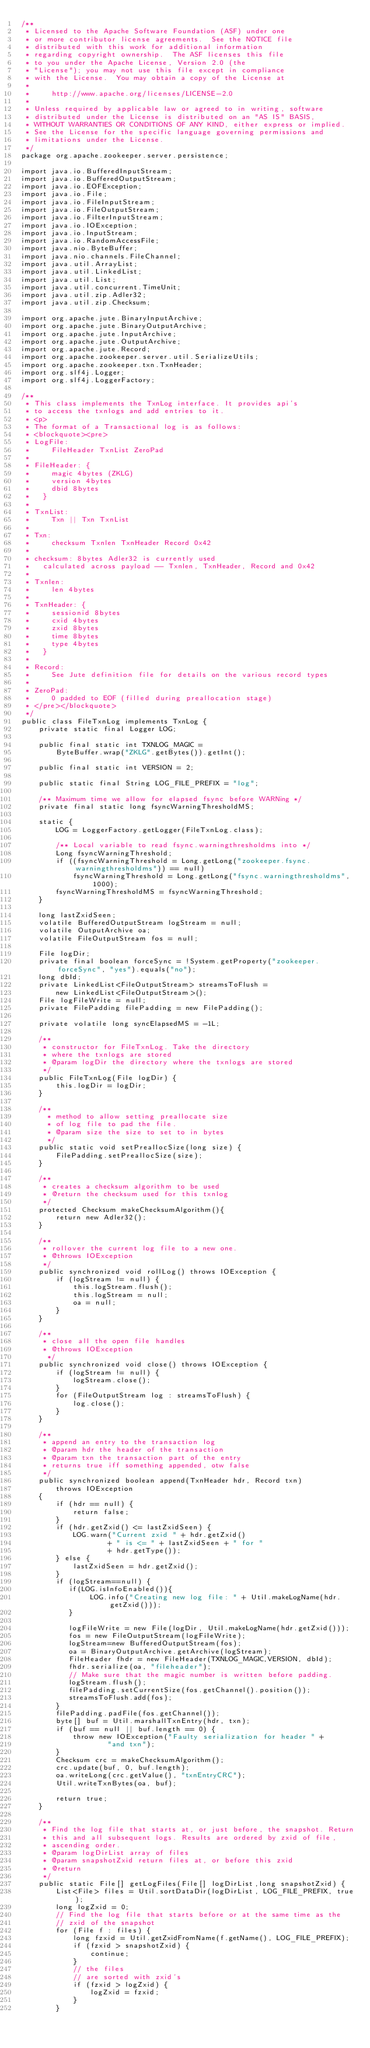Convert code to text. <code><loc_0><loc_0><loc_500><loc_500><_Java_>/**
 * Licensed to the Apache Software Foundation (ASF) under one
 * or more contributor license agreements.  See the NOTICE file
 * distributed with this work for additional information
 * regarding copyright ownership.  The ASF licenses this file
 * to you under the Apache License, Version 2.0 (the
 * "License"); you may not use this file except in compliance
 * with the License.  You may obtain a copy of the License at
 *
 *     http://www.apache.org/licenses/LICENSE-2.0
 *
 * Unless required by applicable law or agreed to in writing, software
 * distributed under the License is distributed on an "AS IS" BASIS,
 * WITHOUT WARRANTIES OR CONDITIONS OF ANY KIND, either express or implied.
 * See the License for the specific language governing permissions and
 * limitations under the License.
 */
package org.apache.zookeeper.server.persistence;

import java.io.BufferedInputStream;
import java.io.BufferedOutputStream;
import java.io.EOFException;
import java.io.File;
import java.io.FileInputStream;
import java.io.FileOutputStream;
import java.io.FilterInputStream;
import java.io.IOException;
import java.io.InputStream;
import java.io.RandomAccessFile;
import java.nio.ByteBuffer;
import java.nio.channels.FileChannel;
import java.util.ArrayList;
import java.util.LinkedList;
import java.util.List;
import java.util.concurrent.TimeUnit;
import java.util.zip.Adler32;
import java.util.zip.Checksum;

import org.apache.jute.BinaryInputArchive;
import org.apache.jute.BinaryOutputArchive;
import org.apache.jute.InputArchive;
import org.apache.jute.OutputArchive;
import org.apache.jute.Record;
import org.apache.zookeeper.server.util.SerializeUtils;
import org.apache.zookeeper.txn.TxnHeader;
import org.slf4j.Logger;
import org.slf4j.LoggerFactory;

/**
 * This class implements the TxnLog interface. It provides api's
 * to access the txnlogs and add entries to it.
 * <p>
 * The format of a Transactional log is as follows:
 * <blockquote><pre>
 * LogFile:
 *     FileHeader TxnList ZeroPad
 *
 * FileHeader: {
 *     magic 4bytes (ZKLG)
 *     version 4bytes
 *     dbid 8bytes
 *   }
 *
 * TxnList:
 *     Txn || Txn TxnList
 *
 * Txn:
 *     checksum Txnlen TxnHeader Record 0x42
 *
 * checksum: 8bytes Adler32 is currently used
 *   calculated across payload -- Txnlen, TxnHeader, Record and 0x42
 *
 * Txnlen:
 *     len 4bytes
 *
 * TxnHeader: {
 *     sessionid 8bytes
 *     cxid 4bytes
 *     zxid 8bytes
 *     time 8bytes
 *     type 4bytes
 *   }
 *
 * Record:
 *     See Jute definition file for details on the various record types
 *
 * ZeroPad:
 *     0 padded to EOF (filled during preallocation stage)
 * </pre></blockquote>
 */
public class FileTxnLog implements TxnLog {
    private static final Logger LOG;

    public final static int TXNLOG_MAGIC =
        ByteBuffer.wrap("ZKLG".getBytes()).getInt();

    public final static int VERSION = 2;

    public static final String LOG_FILE_PREFIX = "log";

    /** Maximum time we allow for elapsed fsync before WARNing */
    private final static long fsyncWarningThresholdMS;

    static {
        LOG = LoggerFactory.getLogger(FileTxnLog.class);

        /** Local variable to read fsync.warningthresholdms into */
        Long fsyncWarningThreshold;
        if ((fsyncWarningThreshold = Long.getLong("zookeeper.fsync.warningthresholdms")) == null)
            fsyncWarningThreshold = Long.getLong("fsync.warningthresholdms", 1000);
        fsyncWarningThresholdMS = fsyncWarningThreshold;
    }

    long lastZxidSeen;
    volatile BufferedOutputStream logStream = null;
    volatile OutputArchive oa;
    volatile FileOutputStream fos = null;

    File logDir;
    private final boolean forceSync = !System.getProperty("zookeeper.forceSync", "yes").equals("no");
    long dbId;
    private LinkedList<FileOutputStream> streamsToFlush =
        new LinkedList<FileOutputStream>();
    File logFileWrite = null;
    private FilePadding filePadding = new FilePadding();

    private volatile long syncElapsedMS = -1L;

    /**
     * constructor for FileTxnLog. Take the directory
     * where the txnlogs are stored
     * @param logDir the directory where the txnlogs are stored
     */
    public FileTxnLog(File logDir) {
        this.logDir = logDir;
    }

    /**
      * method to allow setting preallocate size
      * of log file to pad the file.
      * @param size the size to set to in bytes
      */
    public static void setPreallocSize(long size) {
        FilePadding.setPreallocSize(size);
    }

    /**
     * creates a checksum algorithm to be used
     * @return the checksum used for this txnlog
     */
    protected Checksum makeChecksumAlgorithm(){
        return new Adler32();
    }

    /**
     * rollover the current log file to a new one.
     * @throws IOException
     */
    public synchronized void rollLog() throws IOException {
        if (logStream != null) {
            this.logStream.flush();
            this.logStream = null;
            oa = null;
        }
    }

    /**
     * close all the open file handles
     * @throws IOException
      */
    public synchronized void close() throws IOException {
        if (logStream != null) {
            logStream.close();
        }
        for (FileOutputStream log : streamsToFlush) {
            log.close();
        }
    }

    /**
     * append an entry to the transaction log
     * @param hdr the header of the transaction
     * @param txn the transaction part of the entry
     * returns true iff something appended, otw false
     */
    public synchronized boolean append(TxnHeader hdr, Record txn)
        throws IOException
    {
        if (hdr == null) {
            return false;
        }
        if (hdr.getZxid() <= lastZxidSeen) {
            LOG.warn("Current zxid " + hdr.getZxid()
                    + " is <= " + lastZxidSeen + " for "
                    + hdr.getType());
        } else {
            lastZxidSeen = hdr.getZxid();
        }
        if (logStream==null) {
           if(LOG.isInfoEnabled()){
                LOG.info("Creating new log file: " + Util.makeLogName(hdr.getZxid()));
           }

           logFileWrite = new File(logDir, Util.makeLogName(hdr.getZxid()));
           fos = new FileOutputStream(logFileWrite);
           logStream=new BufferedOutputStream(fos);
           oa = BinaryOutputArchive.getArchive(logStream);
           FileHeader fhdr = new FileHeader(TXNLOG_MAGIC,VERSION, dbId);
           fhdr.serialize(oa, "fileheader");
           // Make sure that the magic number is written before padding.
           logStream.flush();
           filePadding.setCurrentSize(fos.getChannel().position());
           streamsToFlush.add(fos);
        }
        filePadding.padFile(fos.getChannel());
        byte[] buf = Util.marshallTxnEntry(hdr, txn);
        if (buf == null || buf.length == 0) {
            throw new IOException("Faulty serialization for header " +
                    "and txn");
        }
        Checksum crc = makeChecksumAlgorithm();
        crc.update(buf, 0, buf.length);
        oa.writeLong(crc.getValue(), "txnEntryCRC");
        Util.writeTxnBytes(oa, buf);

        return true;
    }

    /**
     * Find the log file that starts at, or just before, the snapshot. Return
     * this and all subsequent logs. Results are ordered by zxid of file,
     * ascending order.
     * @param logDirList array of files
     * @param snapshotZxid return files at, or before this zxid
     * @return
     */
    public static File[] getLogFiles(File[] logDirList,long snapshotZxid) {
        List<File> files = Util.sortDataDir(logDirList, LOG_FILE_PREFIX, true);
        long logZxid = 0;
        // Find the log file that starts before or at the same time as the
        // zxid of the snapshot
        for (File f : files) {
            long fzxid = Util.getZxidFromName(f.getName(), LOG_FILE_PREFIX);
            if (fzxid > snapshotZxid) {
                continue;
            }
            // the files
            // are sorted with zxid's
            if (fzxid > logZxid) {
                logZxid = fzxid;
            }
        }</code> 